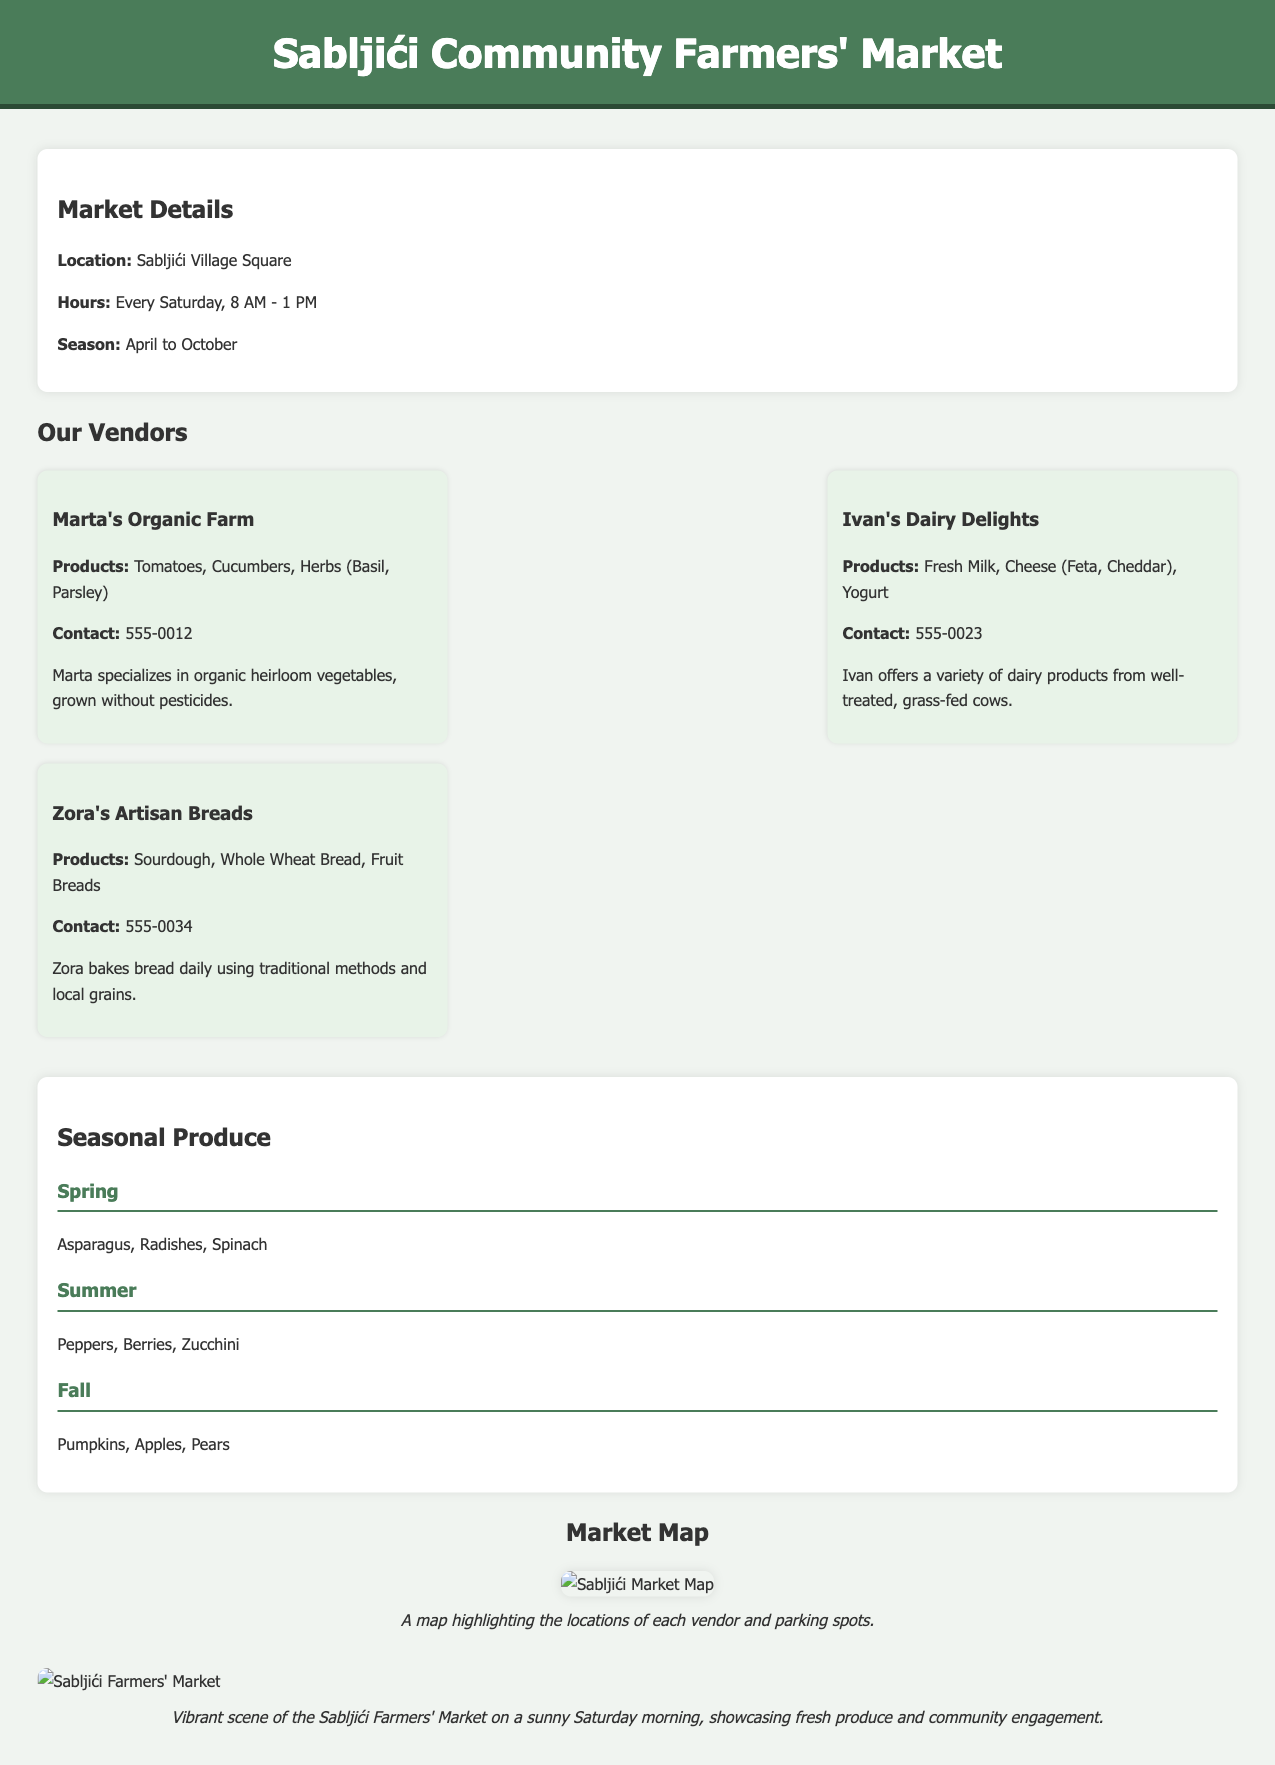What is the location of the market? The location is stated in the market details section, specifically mentioning Sabljići Village Square.
Answer: Sabljići Village Square What are the market hours? The document specifies that the market operates every Saturday from 8 AM to 1 PM.
Answer: Every Saturday, 8 AM - 1 PM Who is the vendor that sells organic vegetables? The document includes a vendor section where Marta's Organic Farm is specified as the one selling organic vegetables.
Answer: Marta's Organic Farm Which seasonal produce is available in summer? The seasonal produce section lists peppers, berries, and zucchini specifically for the summer season.
Answer: Peppers, Berries, Zucchini How many vendors are presented in the document? By counting the vendor listings, the document shows three vendors: Marta, Ivan, and Zora.
Answer: 3 What type of bread does Zora sell? The vendor section indicates that Zora sells sourdough and whole wheat bread, among others.
Answer: Sourdough, Whole Wheat Bread What contact number is listed for Ivan's Dairy Delights? The vendor information clearly states the contact number for Ivan's Dairy Delights is 555-0023.
Answer: 555-0023 What can you find on the market map? The map section mentions that it highlights locations of vendors and parking spots.
Answer: Vendor locations and parking spots During which months is the market open? The market details state that it is open from April to October.
Answer: April to October 